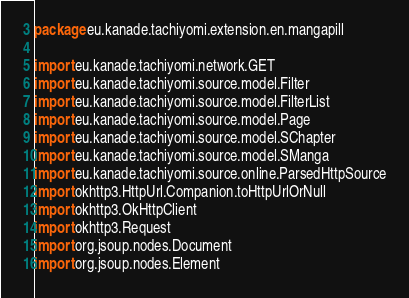<code> <loc_0><loc_0><loc_500><loc_500><_Kotlin_>package eu.kanade.tachiyomi.extension.en.mangapill

import eu.kanade.tachiyomi.network.GET
import eu.kanade.tachiyomi.source.model.Filter
import eu.kanade.tachiyomi.source.model.FilterList
import eu.kanade.tachiyomi.source.model.Page
import eu.kanade.tachiyomi.source.model.SChapter
import eu.kanade.tachiyomi.source.model.SManga
import eu.kanade.tachiyomi.source.online.ParsedHttpSource
import okhttp3.HttpUrl.Companion.toHttpUrlOrNull
import okhttp3.OkHttpClient
import okhttp3.Request
import org.jsoup.nodes.Document
import org.jsoup.nodes.Element
</code> 